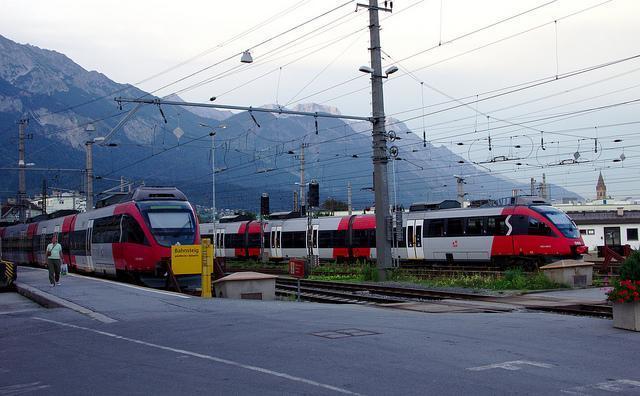How many different trains are there?
Give a very brief answer. 2. How many people are walking in the photo?
Give a very brief answer. 1. How many trains are there?
Give a very brief answer. 2. 